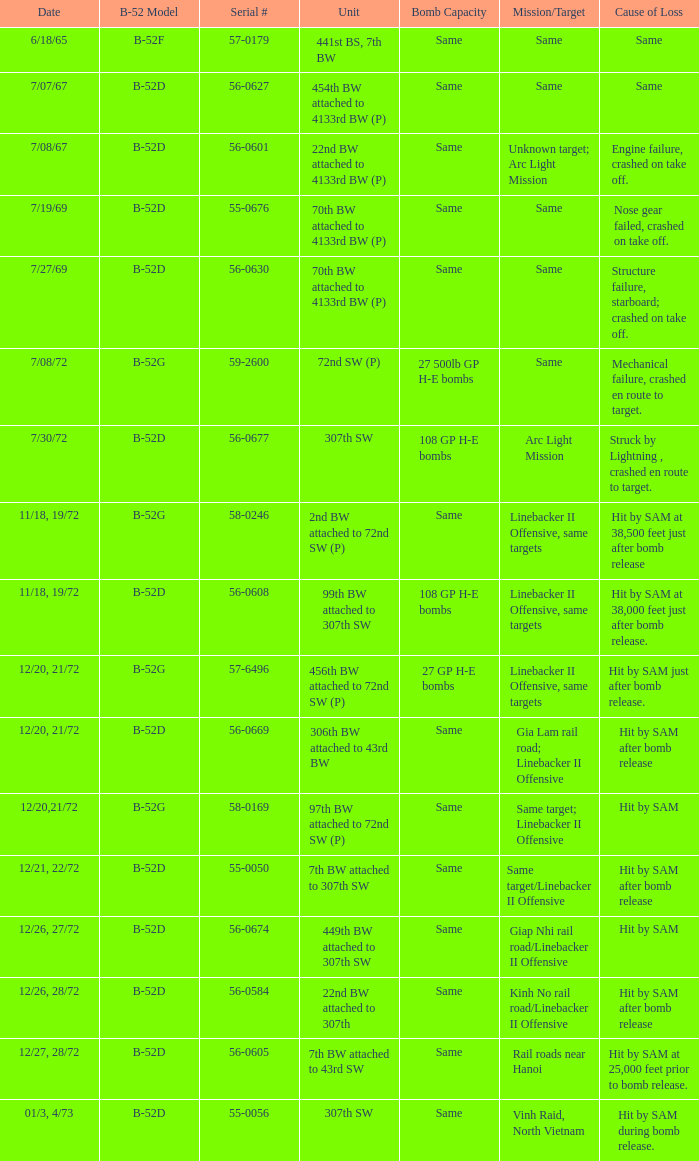When 7th bw attached to 43rd sw is the unit what is the b-52 model? B-52D. 